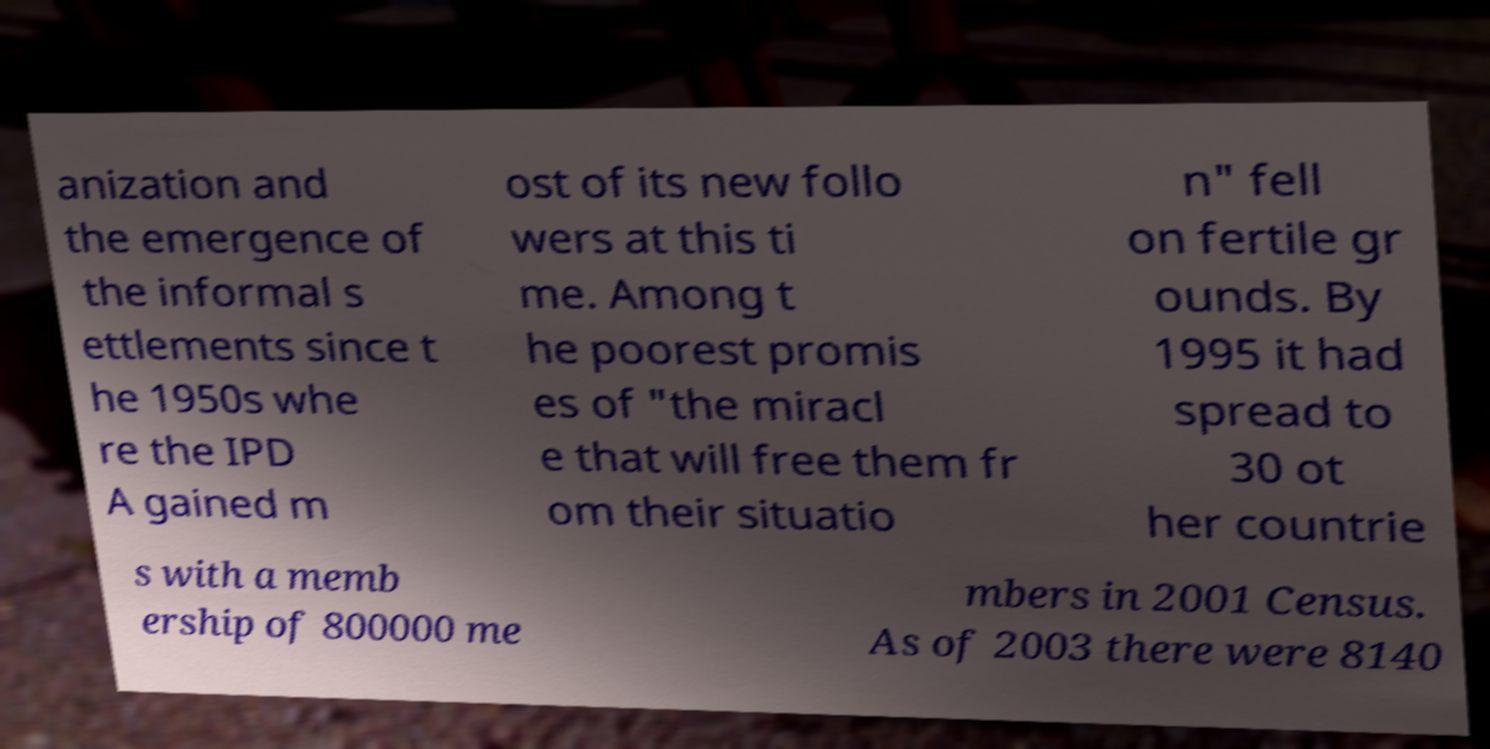There's text embedded in this image that I need extracted. Can you transcribe it verbatim? anization and the emergence of the informal s ettlements since t he 1950s whe re the IPD A gained m ost of its new follo wers at this ti me. Among t he poorest promis es of "the miracl e that will free them fr om their situatio n" fell on fertile gr ounds. By 1995 it had spread to 30 ot her countrie s with a memb ership of 800000 me mbers in 2001 Census. As of 2003 there were 8140 